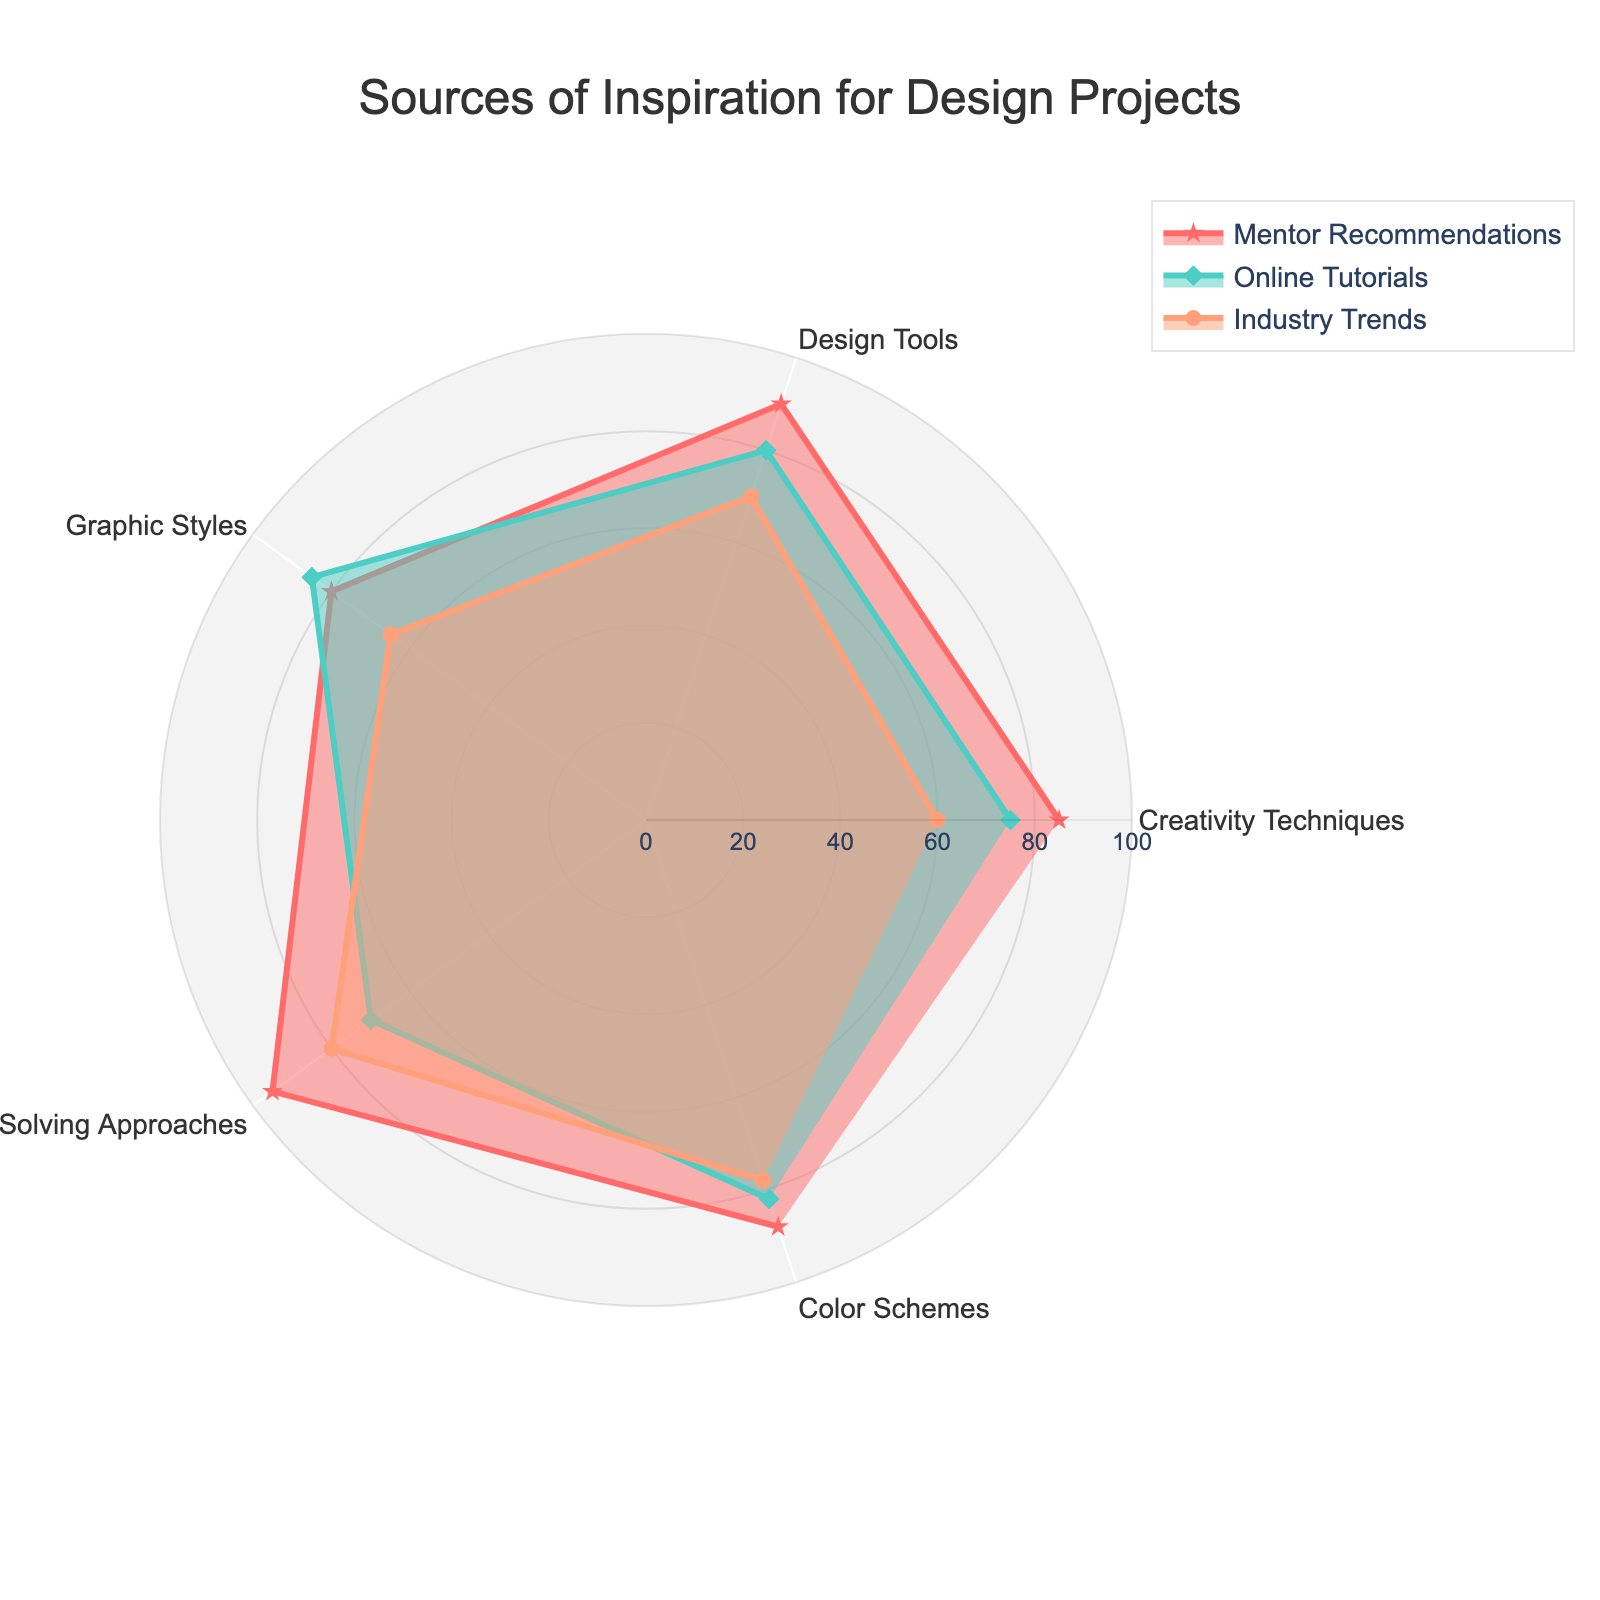What's the title of the figure? The title usually appears at the top of the chart and provides an overview of what the chart represents.
Answer: Sources of Inspiration for Design Projects What category has the highest score in "Design Tools" for Mentor Recommendations? To answer this, look for the data series labeled "Mentor Recommendations" and identify the highest point on the design tools axis.
Answer: 90 Compare "Online Tutorials" and "Industry Trends" in "Problem-Solving Approaches". Which one is higher? Check the values represented by the two groups for "Problem-Solving Approaches"; "Online Tutorials" is at 70, and "Industry Trends" is at 80.
Answer: Industry Trends What is the average score of "Color Schemes" across all groups? Sum the values for all three groups in "Color Schemes" and divide by 3: (88 + 82 + 78) / 3 = 82.67.
Answer: 82.67 Which category has the lowest score in "Industry Trends"? Look for the "Industry Trends" group and identify the category with the smallest value, which is "Creativity Techniques" with a score of 60.
Answer: Creativity Techniques What is the difference between the highest and lowest scores for "Mentor Recommendations"? Identify the highest score (95 in "Problem-Solving Approaches") and the lowest score (80 in "Graphic Styles"), then find the difference: 95 - 80 = 15.
Answer: 15 Does "Online Tutorials" always have higher scores than "Industry Trends"? Compare the values for "Online Tutorials" and "Industry Trends" across all categories. In "Problem-Solving Approaches" and "Graphic Styles", "Online Tutorials" have higher scores, but in "Color Schemes", "Industry Trends" is higher.
Answer: No Which category shows the most significant variation between the three groups? Analyze each category for variations by finding the range of scores (max - min). "Problem-Solving Approaches" has the highest score of 95 and lowest of 70, giving a range of 25.
Answer: Problem-Solving Approaches What's the total score for "Online Tutorials" across all categories? Sum the scores for "Online Tutorials" in all categories: 75 + 80 + 85 + 70 + 82 = 392.
Answer: 392 